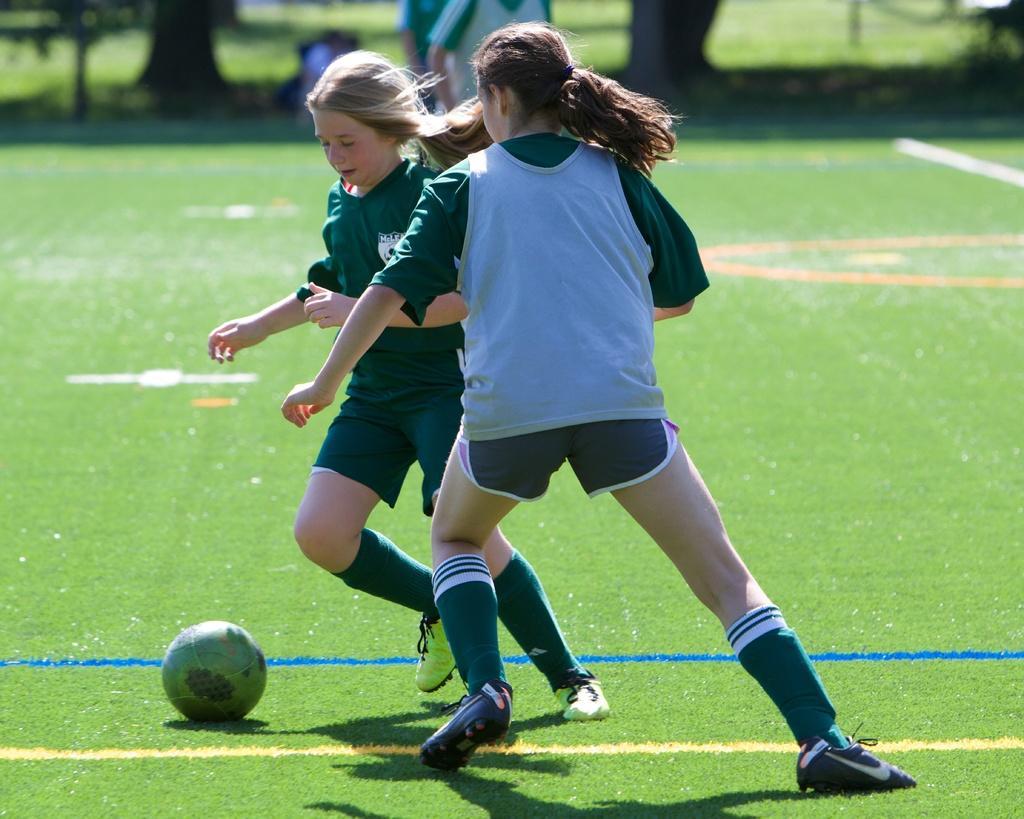Please provide a concise description of this image. The image is taken in a football ground. In the foreground of the picture there are two girls playing football. At the bottom there is grass. In the background there are people, trees, plants and grass. 